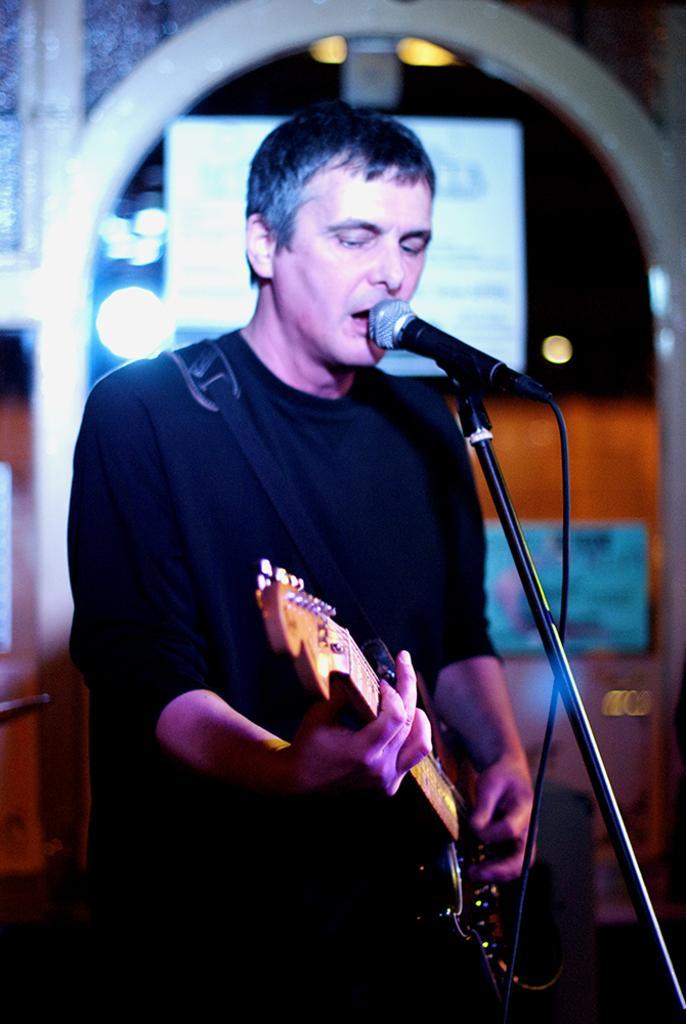Please provide a concise description of this image. In this image I see a man who is holding a guitar and is in front of a mic. 